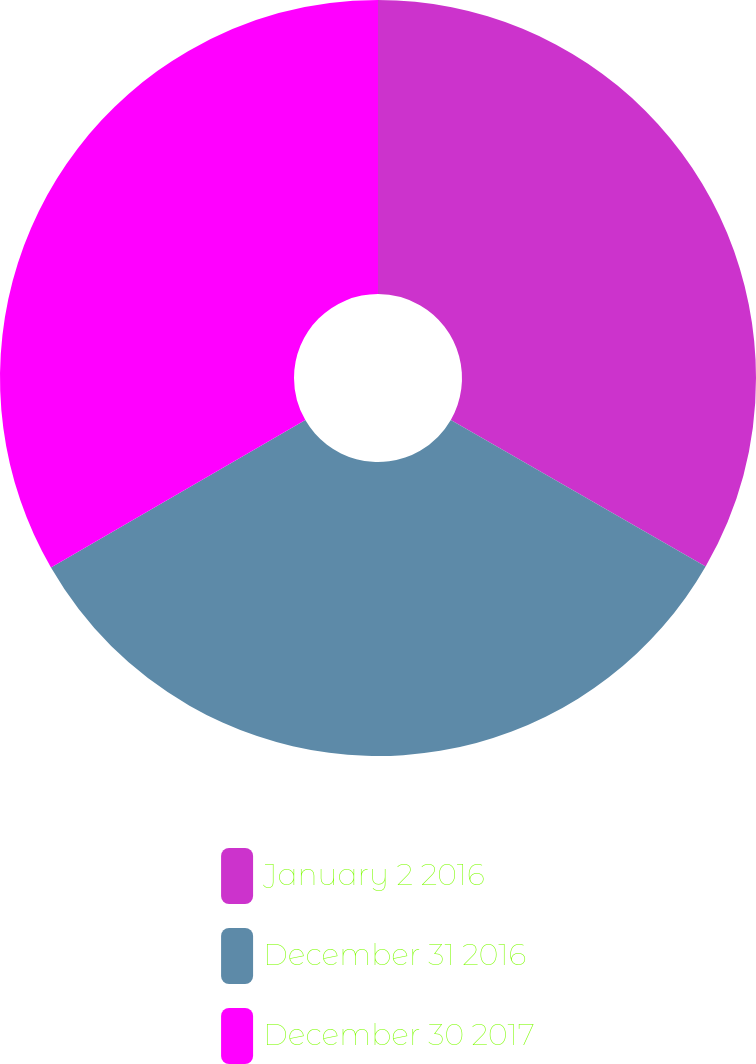Convert chart to OTSL. <chart><loc_0><loc_0><loc_500><loc_500><pie_chart><fcel>January 2 2016<fcel>December 31 2016<fcel>December 30 2017<nl><fcel>33.31%<fcel>33.33%<fcel>33.36%<nl></chart> 